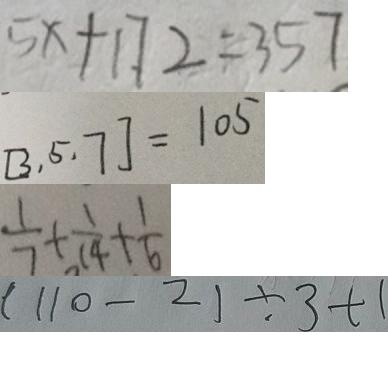Convert formula to latex. <formula><loc_0><loc_0><loc_500><loc_500>5 x + 1 7 2 = 3 5 7 
 [ 3 , 5 , 7 ] = 1 0 5 
 \frac { 1 } { 7 } + \frac { 1 } { 1 4 } + \frac { 1 } { 6 } 
 ( 1 1 0 - 2 ) \div 3 + 1</formula> 